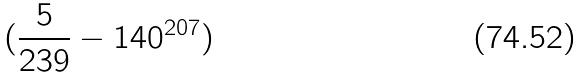Convert formula to latex. <formula><loc_0><loc_0><loc_500><loc_500>( \frac { 5 } { 2 3 9 } - 1 4 0 ^ { 2 0 7 } )</formula> 